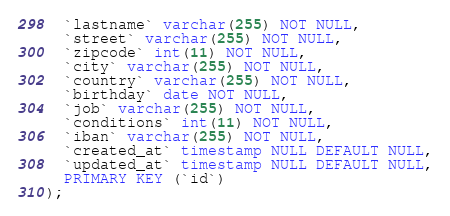<code> <loc_0><loc_0><loc_500><loc_500><_SQL_>  `lastname` varchar(255) NOT NULL,
  `street` varchar(255) NOT NULL,
  `zipcode` int(11) NOT NULL,
  `city` varchar(255) NOT NULL,
  `country` varchar(255) NOT NULL,
  `birthday` date NOT NULL,
  `job` varchar(255) NOT NULL,
  `conditions` int(11) NOT NULL,
  `iban` varchar(255) NOT NULL,
  `created_at` timestamp NULL DEFAULT NULL,
  `updated_at` timestamp NULL DEFAULT NULL,
  PRIMARY KEY (`id`)
);

</code> 